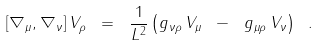<formula> <loc_0><loc_0><loc_500><loc_500>[ \nabla _ { \mu } , \nabla _ { \nu } ] \, V _ { \rho } \ = \ \frac { 1 } { L ^ { 2 } } \left ( g _ { \nu \rho } \, V _ { \mu } \ - \ g _ { \mu \rho } \, V _ { \nu } \right ) \ .</formula> 